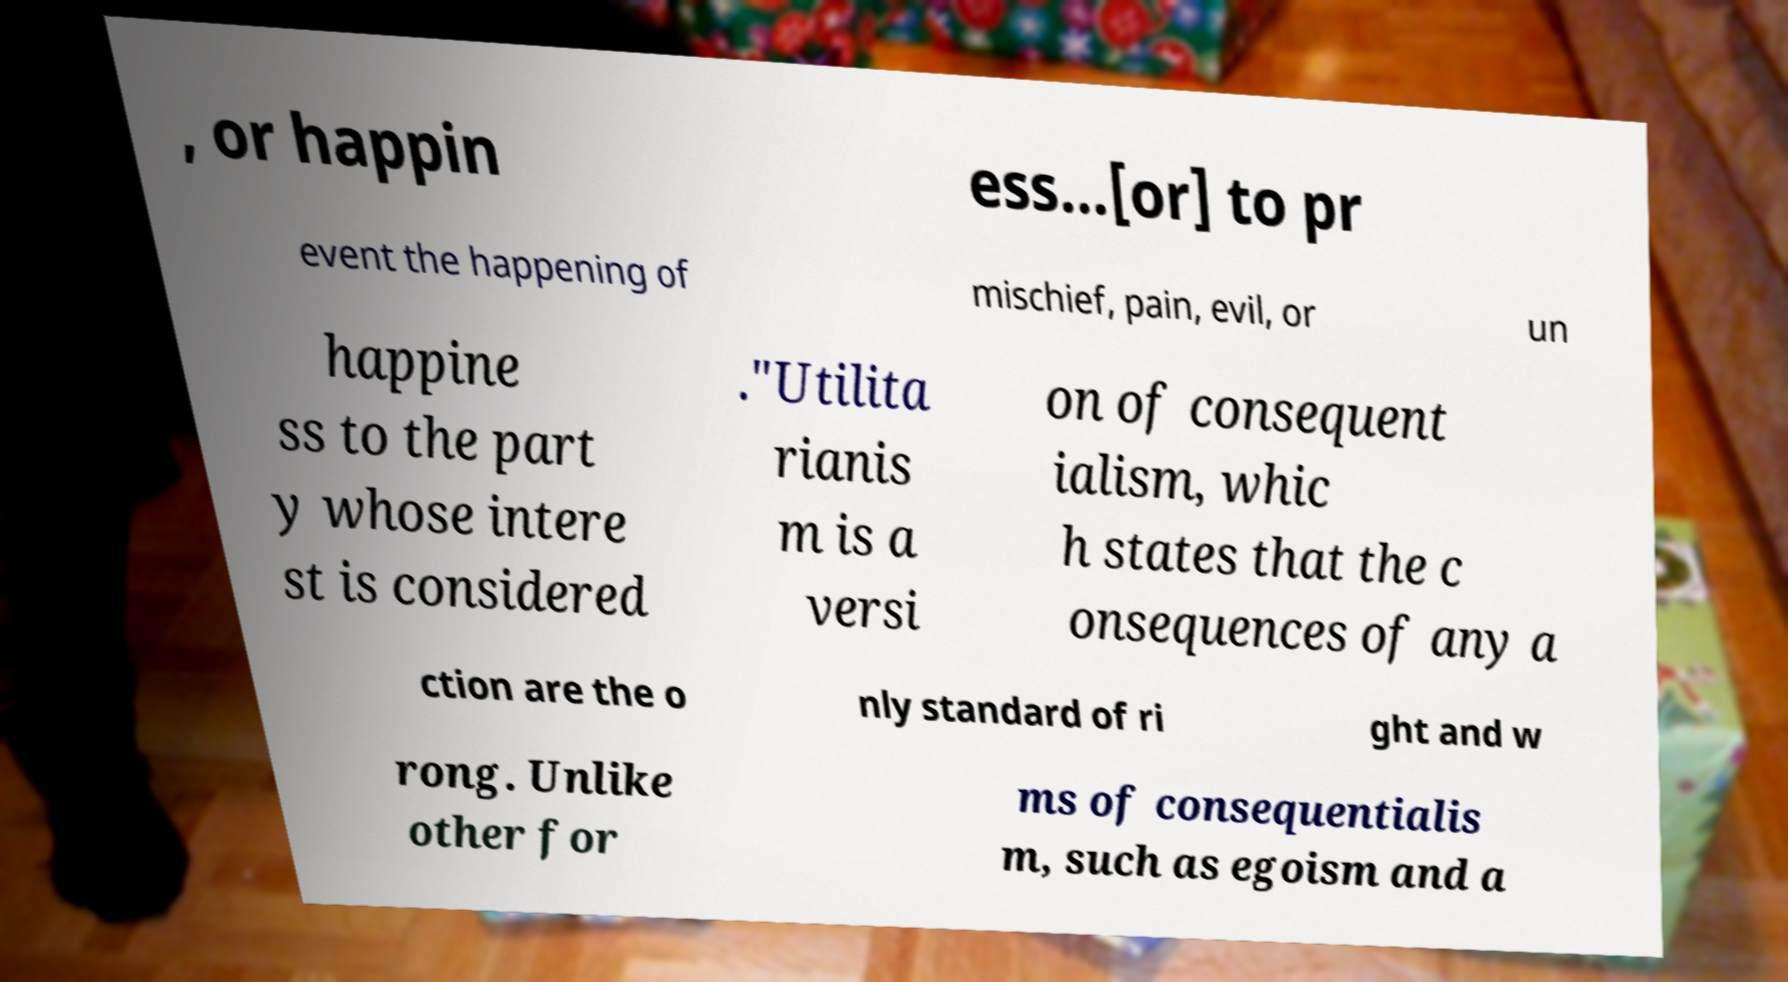What messages or text are displayed in this image? I need them in a readable, typed format. , or happin ess...[or] to pr event the happening of mischief, pain, evil, or un happine ss to the part y whose intere st is considered ."Utilita rianis m is a versi on of consequent ialism, whic h states that the c onsequences of any a ction are the o nly standard of ri ght and w rong. Unlike other for ms of consequentialis m, such as egoism and a 